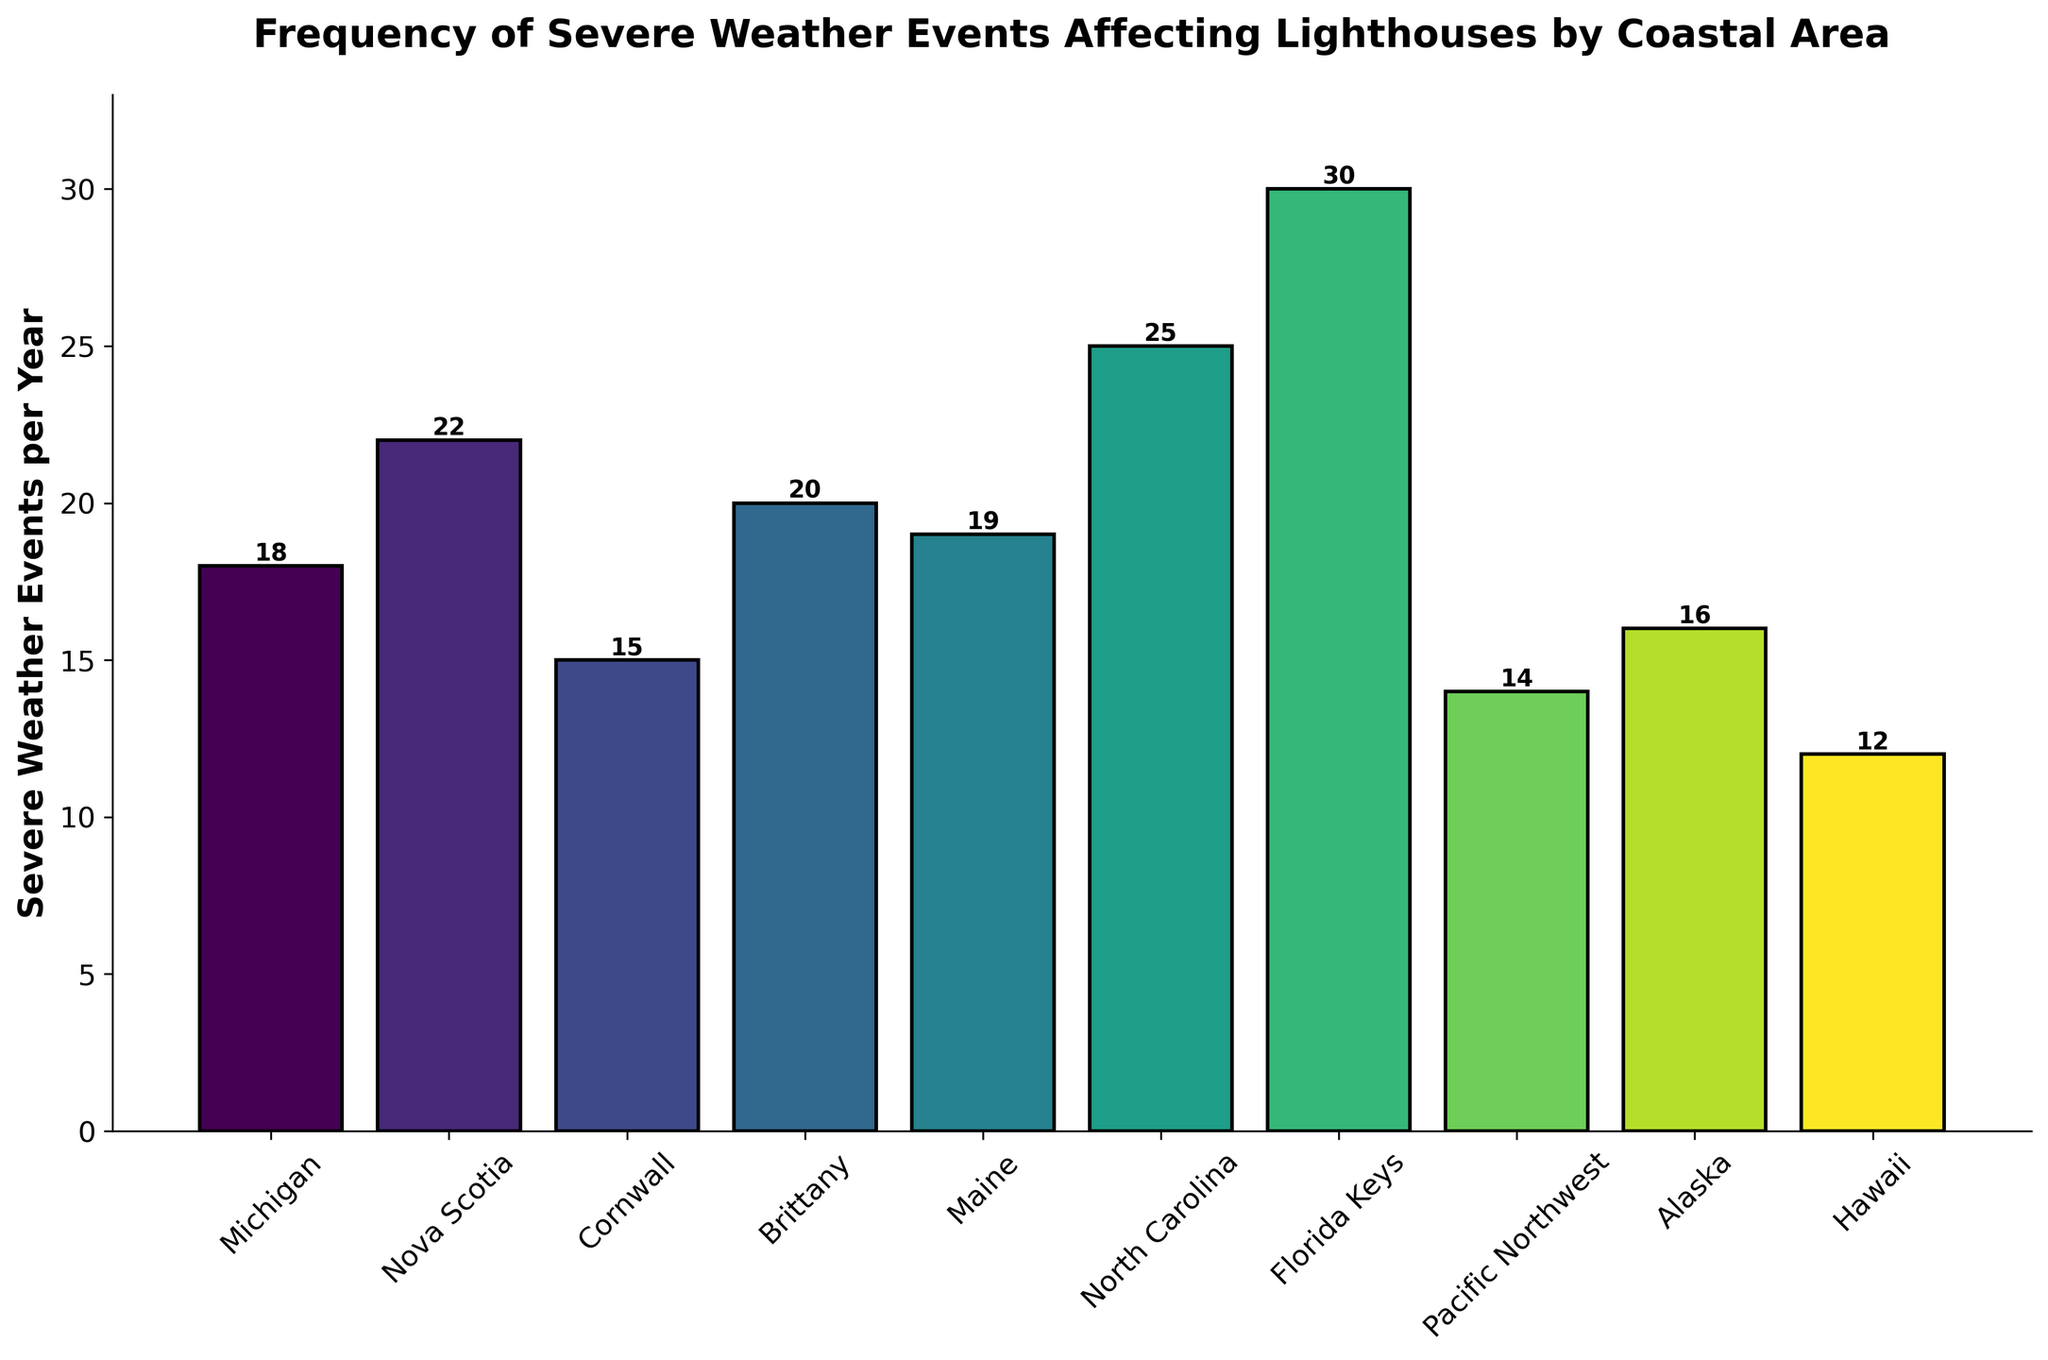What is the average number of severe weather events affecting lighthouses per year across all coastal regions? First, sum up the number of severe weather events for all regions: 18 (Michigan) + 22 (Nova Scotia) + 15 (Cornwall) + 20 (Brittany) + 19 (Maine) + 25 (North Carolina) + 30 (Florida Keys) + 14 (Pacific Northwest) + 16 (Alaska) + 12 (Hawaii) = 191. Then divide by the number of regions (10): 191 / 10 = 19.1
Answer: 19.1 Which coastal region experiences the highest number of severe weather events per year? Look for the tallest bar in the chart. The tallest bar corresponds to Florida Keys, which has 30 severe weather events per year.
Answer: Florida Keys What is the difference in the number of severe weather events between the Florida Keys and Michigan? Florida Keys has 30 events, and Michigan has 18 events. Subtract Michigan's events from Florida Keys' events: 30 - 18 = 12.
Answer: 12 Which regions have fewer severe weather events per year than Alaska? Alaska has 16 events per year. Regions with fewer events than Alaska are Cornwall (15), Pacific Northwest (14), and Hawaii (12).
Answer: Cornwall, Pacific Northwest, Hawaii What is the sum of severe weather events per year for North Carolina and Maine? North Carolina has 25 events, and Maine has 19 events. Add these together: 25 + 19 = 44.
Answer: 44 Which coastal regions have an equal number of severe weather events per year? By examining the height of the bars, no two bars have the exact same height, indicating that no two regions have the same number of severe weather events per year.
Answer: None Is the number of severe weather events greater in Nova Scotia or Brittany, and by how much? Nova Scotia has 22 events, and Brittany has 20 events. Subtract Brittany's events from Nova Scotia's events: 22 - 20 = 2.
Answer: Nova Scotia by 2 Which coastal region is represented by the shortest bar and what is the number of severe weather events? The shortest bar corresponds to Hawaii, which has 12 severe weather events per year.
Answer: Hawaii with 12 How many regions experience more than 20 severe weather events per year, and which are they? Regions with more than 20 events are Nova Scotia (22), North Carolina (25), and Florida Keys (30). There are 3 regions in total.
Answer: 3; Nova Scotia, North Carolina, Florida Keys What is the range of severe weather events per year across the coastal regions? The range is found by subtracting the smallest value from the largest value. The smallest is Hawaii with 12 events and the largest is the Florida Keys with 30 events. Thus, 30 - 12 = 18.
Answer: 18 